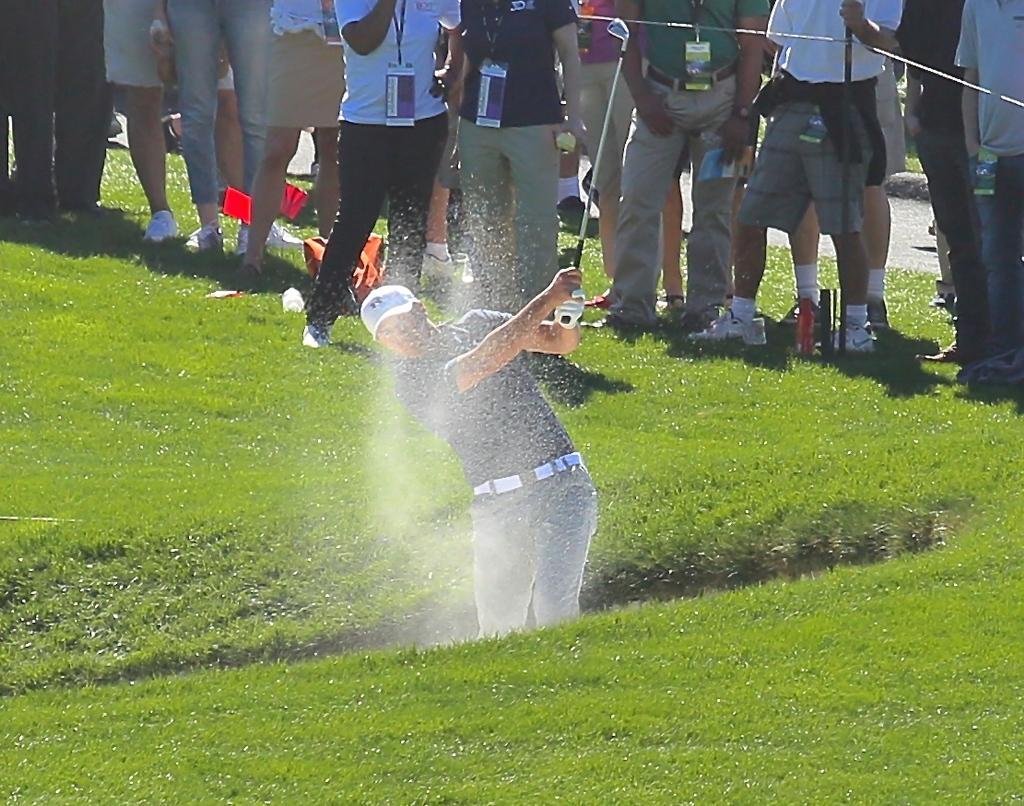Could you give a brief overview of what you see in this image? In the picture we can see a grass surface on it, we can see a man playing a hockey and hitting a ball, he is wearing a T-shirt and a white cap and behind him we can see some people are standing with hockey sticks and behind them we can see a path. 